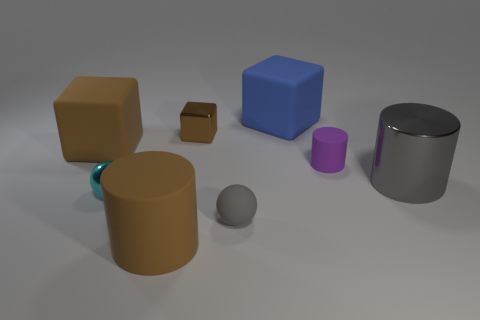Add 1 big blue things. How many objects exist? 9 Subtract all matte blocks. How many blocks are left? 1 Subtract all cyan spheres. How many spheres are left? 1 Subtract all cubes. How many objects are left? 5 Subtract 1 cubes. How many cubes are left? 2 Add 3 big rubber cubes. How many big rubber cubes are left? 5 Add 2 cyan metallic objects. How many cyan metallic objects exist? 3 Subtract 0 green cubes. How many objects are left? 8 Subtract all purple balls. Subtract all red blocks. How many balls are left? 2 Subtract all red cylinders. How many green blocks are left? 0 